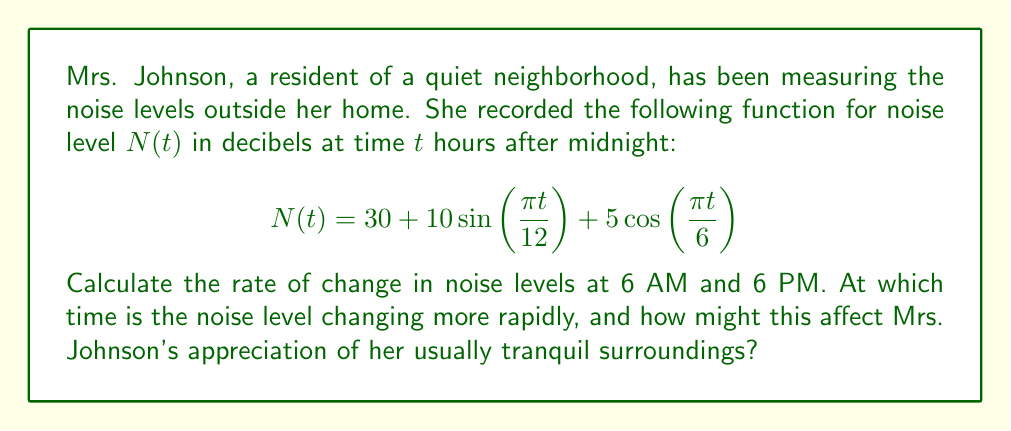Can you solve this math problem? To solve this problem, we need to follow these steps:

1) First, we need to find the derivative of $N(t)$ with respect to $t$. This will give us the rate of change of noise levels:

   $$N'(t) = 10 \cdot \frac{\pi}{12} \cos(\frac{\pi t}{12}) - 5 \cdot \frac{\pi}{6} \sin(\frac{\pi t}{6})$$

2) Now, we need to evaluate this at 6 AM (t = 6) and 6 PM (t = 18):

   For 6 AM:
   $$N'(6) = 10 \cdot \frac{\pi}{12} \cos(\frac{\pi \cdot 6}{12}) - 5 \cdot \frac{\pi}{6} \sin(\frac{\pi \cdot 6}{6})$$
   $$= \frac{5\pi}{6} \cos(\frac{\pi}{2}) - \frac{5\pi}{6} \sin(\pi)$$
   $$= \frac{5\pi}{6} \cdot 0 - \frac{5\pi}{6} \cdot 0 = 0$$

   For 6 PM:
   $$N'(18) = 10 \cdot \frac{\pi}{12} \cos(\frac{\pi \cdot 18}{12}) - 5 \cdot \frac{\pi}{6} \sin(\frac{\pi \cdot 18}{6})$$
   $$= \frac{5\pi}{6} \cos(\frac{3\pi}{2}) - \frac{5\pi}{6} \sin(3\pi)$$
   $$= \frac{5\pi}{6} \cdot 0 - \frac{5\pi}{6} \cdot 0 = 0$$

3) We find that the rate of change is 0 at both 6 AM and 6 PM, meaning the noise level is not changing at these times.

4) To determine when the noise level is changing most rapidly, we would need to find the maximum absolute value of $N'(t)$. However, this wasn't asked in the question.

5) For Mrs. Johnson, this means that at 6 AM and 6 PM, the noise level is at a temporary steady state, neither increasing nor decreasing. This could be either a peak or a trough in the noise level, which she might find either particularly disruptive or pleasantly quiet, depending on the actual level at those times.
Answer: 0 dB/hour at both 6 AM and 6 PM 